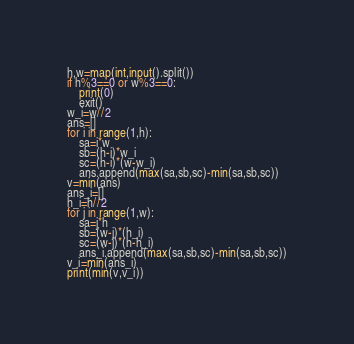<code> <loc_0><loc_0><loc_500><loc_500><_Python_>h,w=map(int,input().split())
if h%3==0 or w%3==0:
    print(0)
    exit()
w_i=w//2
ans=[]
for i in range(1,h):
    sa=i*w
    sb=(h-i)*w_i
    sc=(h-i)*(w-w_i)
    ans.append(max(sa,sb,sc)-min(sa,sb,sc))
v=min(ans)
ans_i=[]
h_i=h//2
for j in range(1,w):
    sa=j*h
    sb=(w-j)*(h_i)
    sc=(w-j)*(h-h_i)
    ans_i.append(max(sa,sb,sc)-min(sa,sb,sc))
v_i=min(ans_i)
print(min(v,v_i))
</code> 